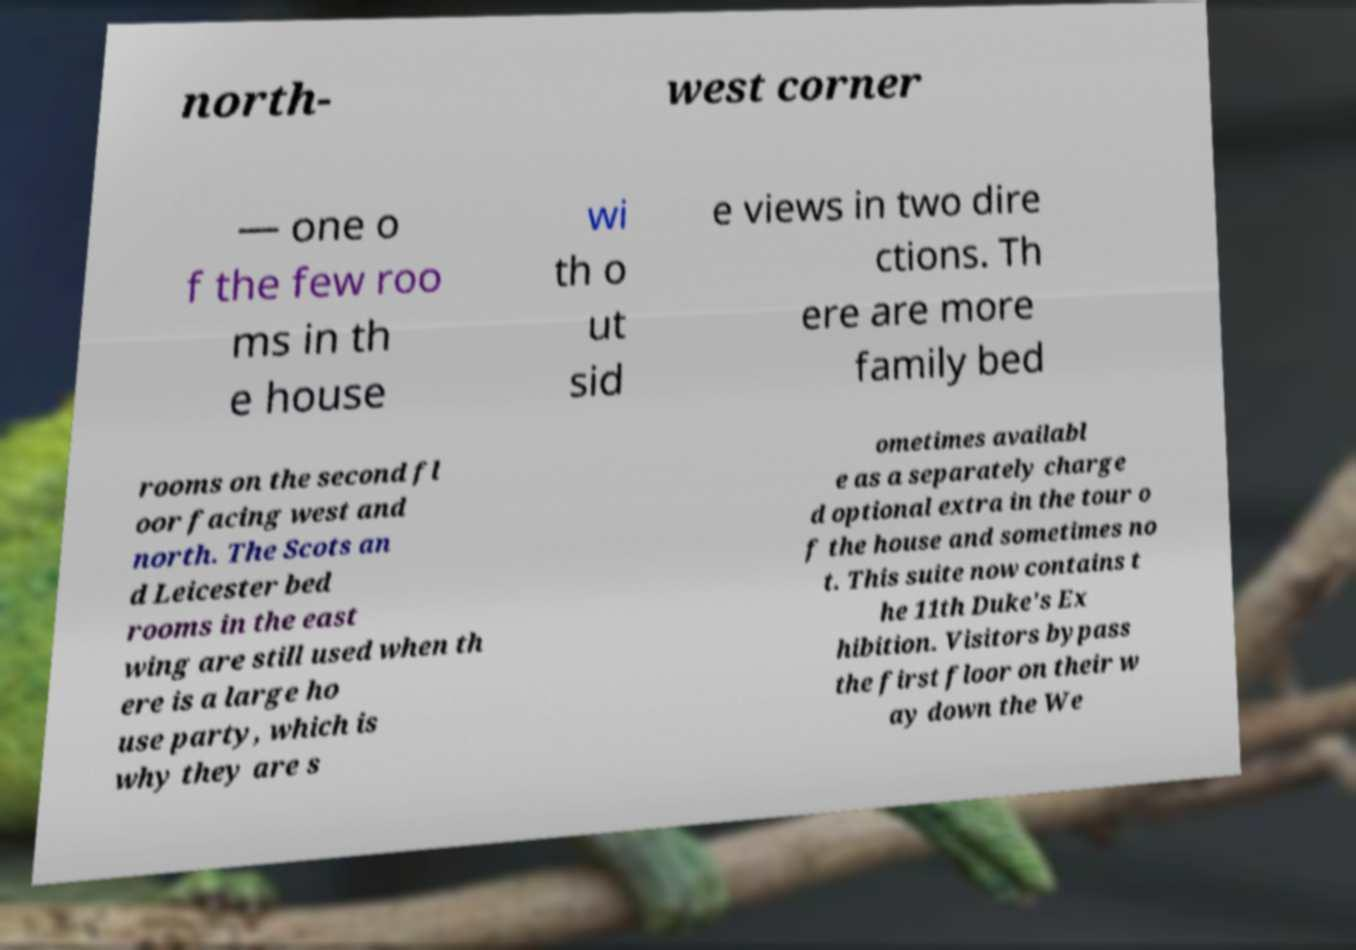Please read and relay the text visible in this image. What does it say? north- west corner — one o f the few roo ms in th e house wi th o ut sid e views in two dire ctions. Th ere are more family bed rooms on the second fl oor facing west and north. The Scots an d Leicester bed rooms in the east wing are still used when th ere is a large ho use party, which is why they are s ometimes availabl e as a separately charge d optional extra in the tour o f the house and sometimes no t. This suite now contains t he 11th Duke's Ex hibition. Visitors bypass the first floor on their w ay down the We 